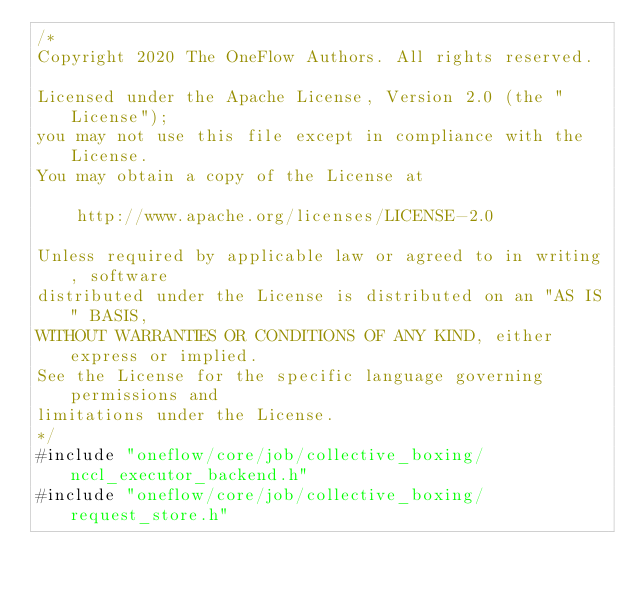<code> <loc_0><loc_0><loc_500><loc_500><_Cuda_>/*
Copyright 2020 The OneFlow Authors. All rights reserved.

Licensed under the Apache License, Version 2.0 (the "License");
you may not use this file except in compliance with the License.
You may obtain a copy of the License at

    http://www.apache.org/licenses/LICENSE-2.0

Unless required by applicable law or agreed to in writing, software
distributed under the License is distributed on an "AS IS" BASIS,
WITHOUT WARRANTIES OR CONDITIONS OF ANY KIND, either express or implied.
See the License for the specific language governing permissions and
limitations under the License.
*/
#include "oneflow/core/job/collective_boxing/nccl_executor_backend.h"
#include "oneflow/core/job/collective_boxing/request_store.h"</code> 